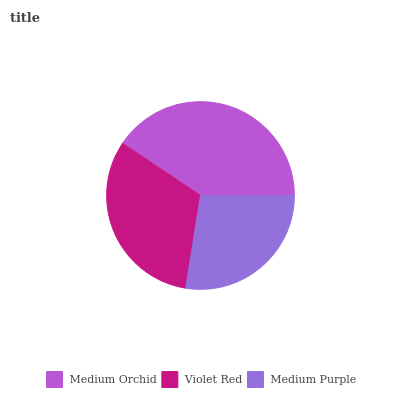Is Medium Purple the minimum?
Answer yes or no. Yes. Is Medium Orchid the maximum?
Answer yes or no. Yes. Is Violet Red the minimum?
Answer yes or no. No. Is Violet Red the maximum?
Answer yes or no. No. Is Medium Orchid greater than Violet Red?
Answer yes or no. Yes. Is Violet Red less than Medium Orchid?
Answer yes or no. Yes. Is Violet Red greater than Medium Orchid?
Answer yes or no. No. Is Medium Orchid less than Violet Red?
Answer yes or no. No. Is Violet Red the high median?
Answer yes or no. Yes. Is Violet Red the low median?
Answer yes or no. Yes. Is Medium Orchid the high median?
Answer yes or no. No. Is Medium Purple the low median?
Answer yes or no. No. 